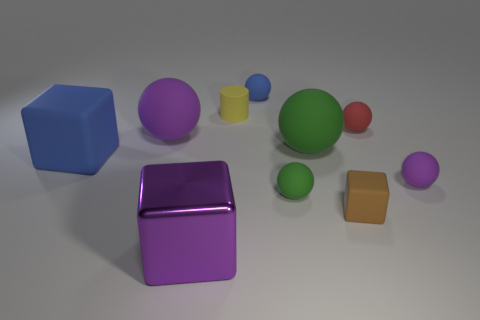How many objects are tiny yellow rubber things or purple rubber things in front of the blue cube?
Provide a short and direct response. 2. Is the number of purple metallic blocks right of the small brown matte object less than the number of objects?
Ensure brevity in your answer.  Yes. There is a purple sphere to the right of the green rubber ball in front of the purple rubber object that is to the right of the tiny blue matte thing; what is its size?
Keep it short and to the point. Small. There is a tiny ball that is both in front of the tiny blue object and on the left side of the tiny brown rubber object; what color is it?
Offer a terse response. Green. How many large blue things are there?
Offer a terse response. 1. Is there anything else that is the same size as the red matte sphere?
Ensure brevity in your answer.  Yes. Do the small brown thing and the large purple block have the same material?
Your answer should be compact. No. There is a blue matte thing that is behind the small red rubber object; is its size the same as the purple rubber thing that is in front of the large blue block?
Give a very brief answer. Yes. Are there fewer big metal blocks than big blue metallic cubes?
Offer a terse response. No. What number of metal things are cubes or yellow cylinders?
Your response must be concise. 1. 